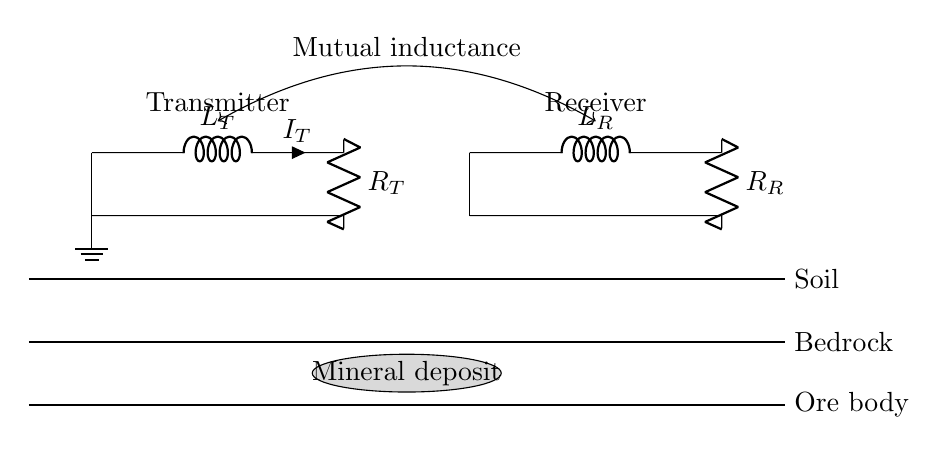What is the value of the transmitter's inductance? The value of the transmitter's inductance is labeled as L_T in the circuit diagram. Since this is a descriptive question, we refer directly to the labeling in the diagram.
Answer: L_T What is the resistance in the receiver circuit? The resistance in the receiver circuit is denoted as R_R in the diagram. This is also a descriptive question asking about a component directly indicated in the circuit.
Answer: R_R How does the transmitter couple with the receiver? The transmitter couples with the receiver through mutual inductance, which is indicated by the label between the two loops in the circuit diagram. This requires understanding the connection shown and the concept of mutual inductance.
Answer: Mutual inductance What are the components present in the transmitter loop? The components present in the transmitter loop include an inductor and a resistor, shown as L_T and R_T, respectively, based on the labels in the circuit diagram. This is a straightforward, descriptive inquiry about the elements in the circuit.
Answer: Inductor and resistor Which geological formation is indicated in the diagram? The diagram indicates three geological formations: soil, bedrock, and ore body. These layers are labeled accordingly beneath the circuit, and it describes the geological context for mineral exploration.
Answer: Soil, bedrock, and ore body What role does the inductor play in this circuit? The inductor in this Resistor-Inductor network serves to store energy in the magnetic field and contributes to the time-dependent response of the circuit when an alternating current is applied. This requires an understanding of the function of inductors in circuits.
Answer: Store energy How do you interpret the mineral deposit's position in the diagram? The mineral deposit is represented as a gray ellipse located between the bedrock and the soil layers. This indicates where the target ore body might be situated in relation to the transmitter and receiver. This involves understanding the geological symbols and their placement.
Answer: Between bedrock and soil 